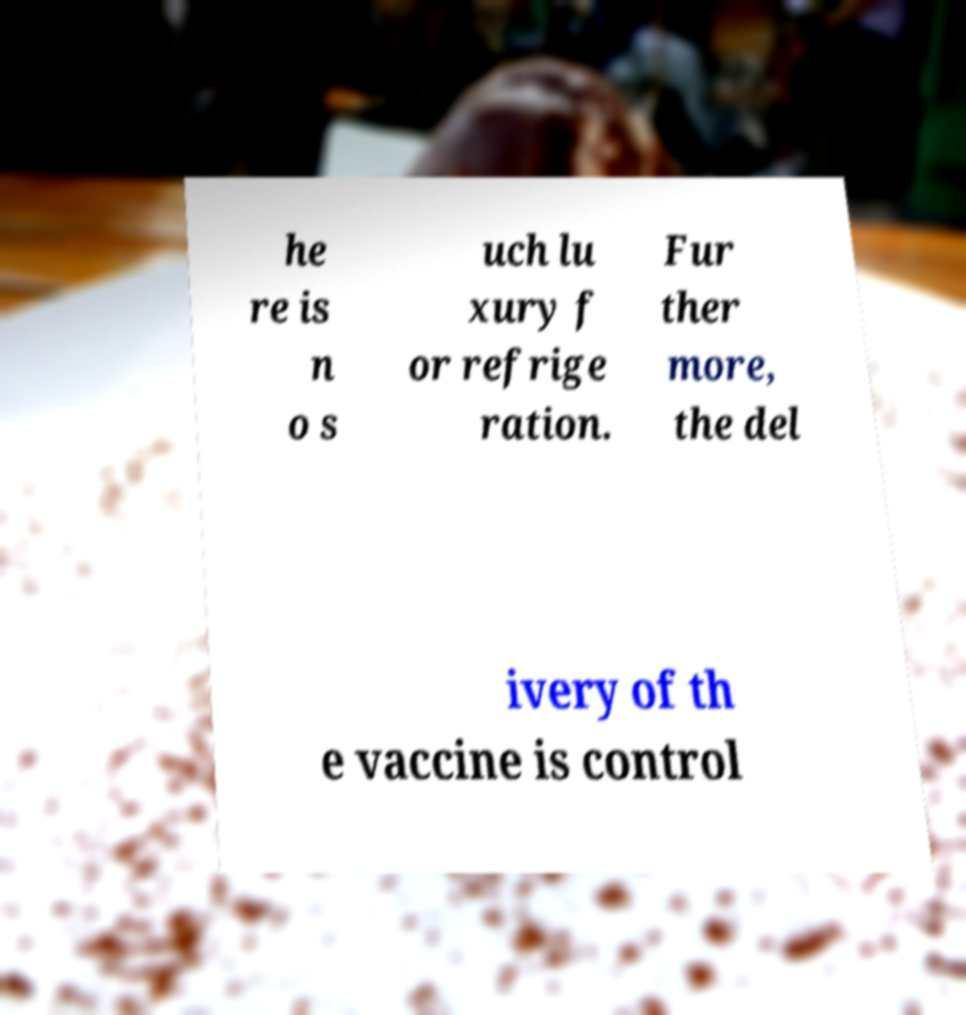For documentation purposes, I need the text within this image transcribed. Could you provide that? he re is n o s uch lu xury f or refrige ration. Fur ther more, the del ivery of th e vaccine is control 